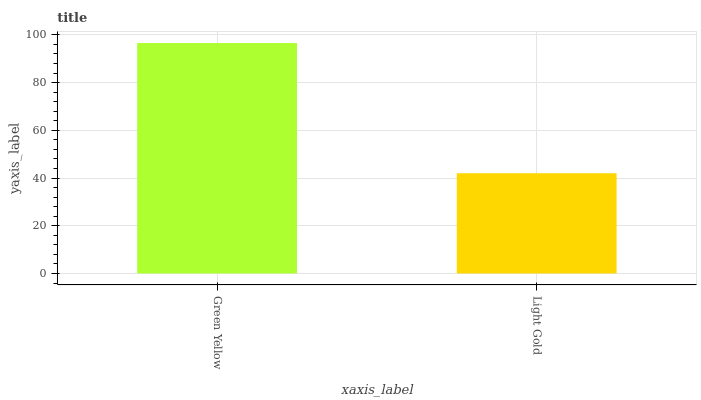Is Light Gold the minimum?
Answer yes or no. Yes. Is Green Yellow the maximum?
Answer yes or no. Yes. Is Light Gold the maximum?
Answer yes or no. No. Is Green Yellow greater than Light Gold?
Answer yes or no. Yes. Is Light Gold less than Green Yellow?
Answer yes or no. Yes. Is Light Gold greater than Green Yellow?
Answer yes or no. No. Is Green Yellow less than Light Gold?
Answer yes or no. No. Is Green Yellow the high median?
Answer yes or no. Yes. Is Light Gold the low median?
Answer yes or no. Yes. Is Light Gold the high median?
Answer yes or no. No. Is Green Yellow the low median?
Answer yes or no. No. 